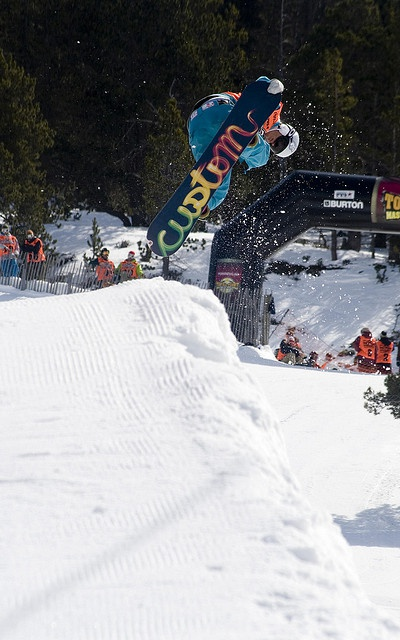Describe the objects in this image and their specific colors. I can see snowboard in black, navy, tan, and gray tones, people in black, blue, and teal tones, people in black, gray, blue, navy, and brown tones, people in black, gray, maroon, and brown tones, and people in black, gray, brown, and darkgray tones in this image. 